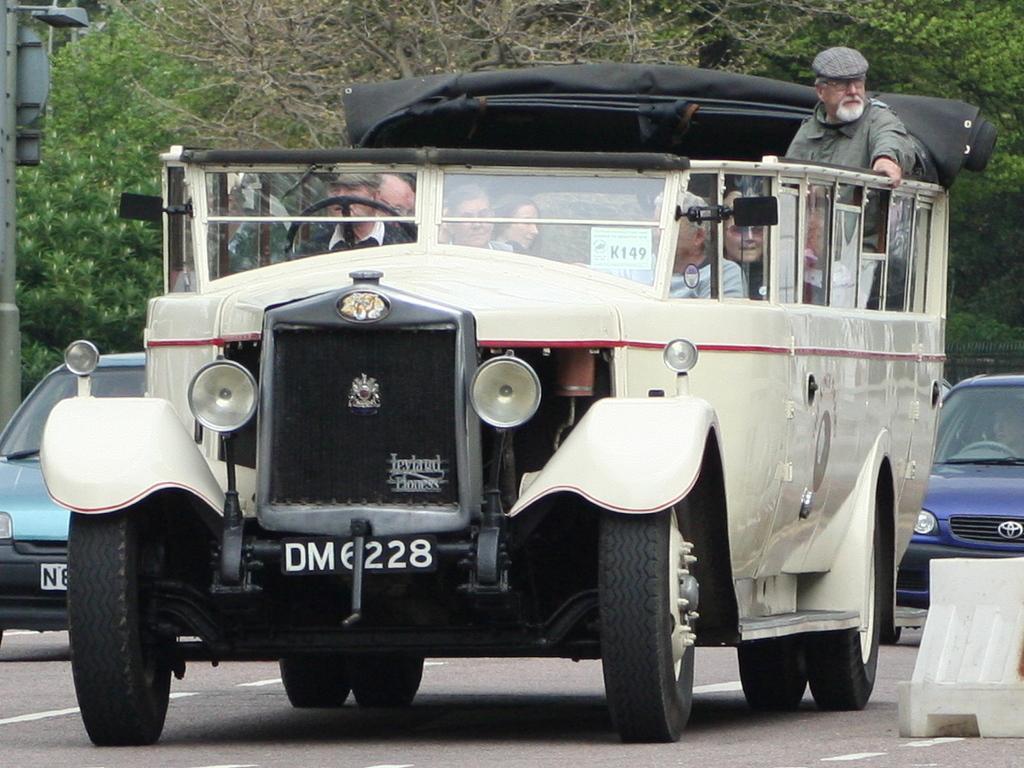How would you summarize this image in a sentence or two? In this picture I can see people sitting in a vehicle. In the background I can see cars on the road and trees. On the right side I can see a white color object on the road. 